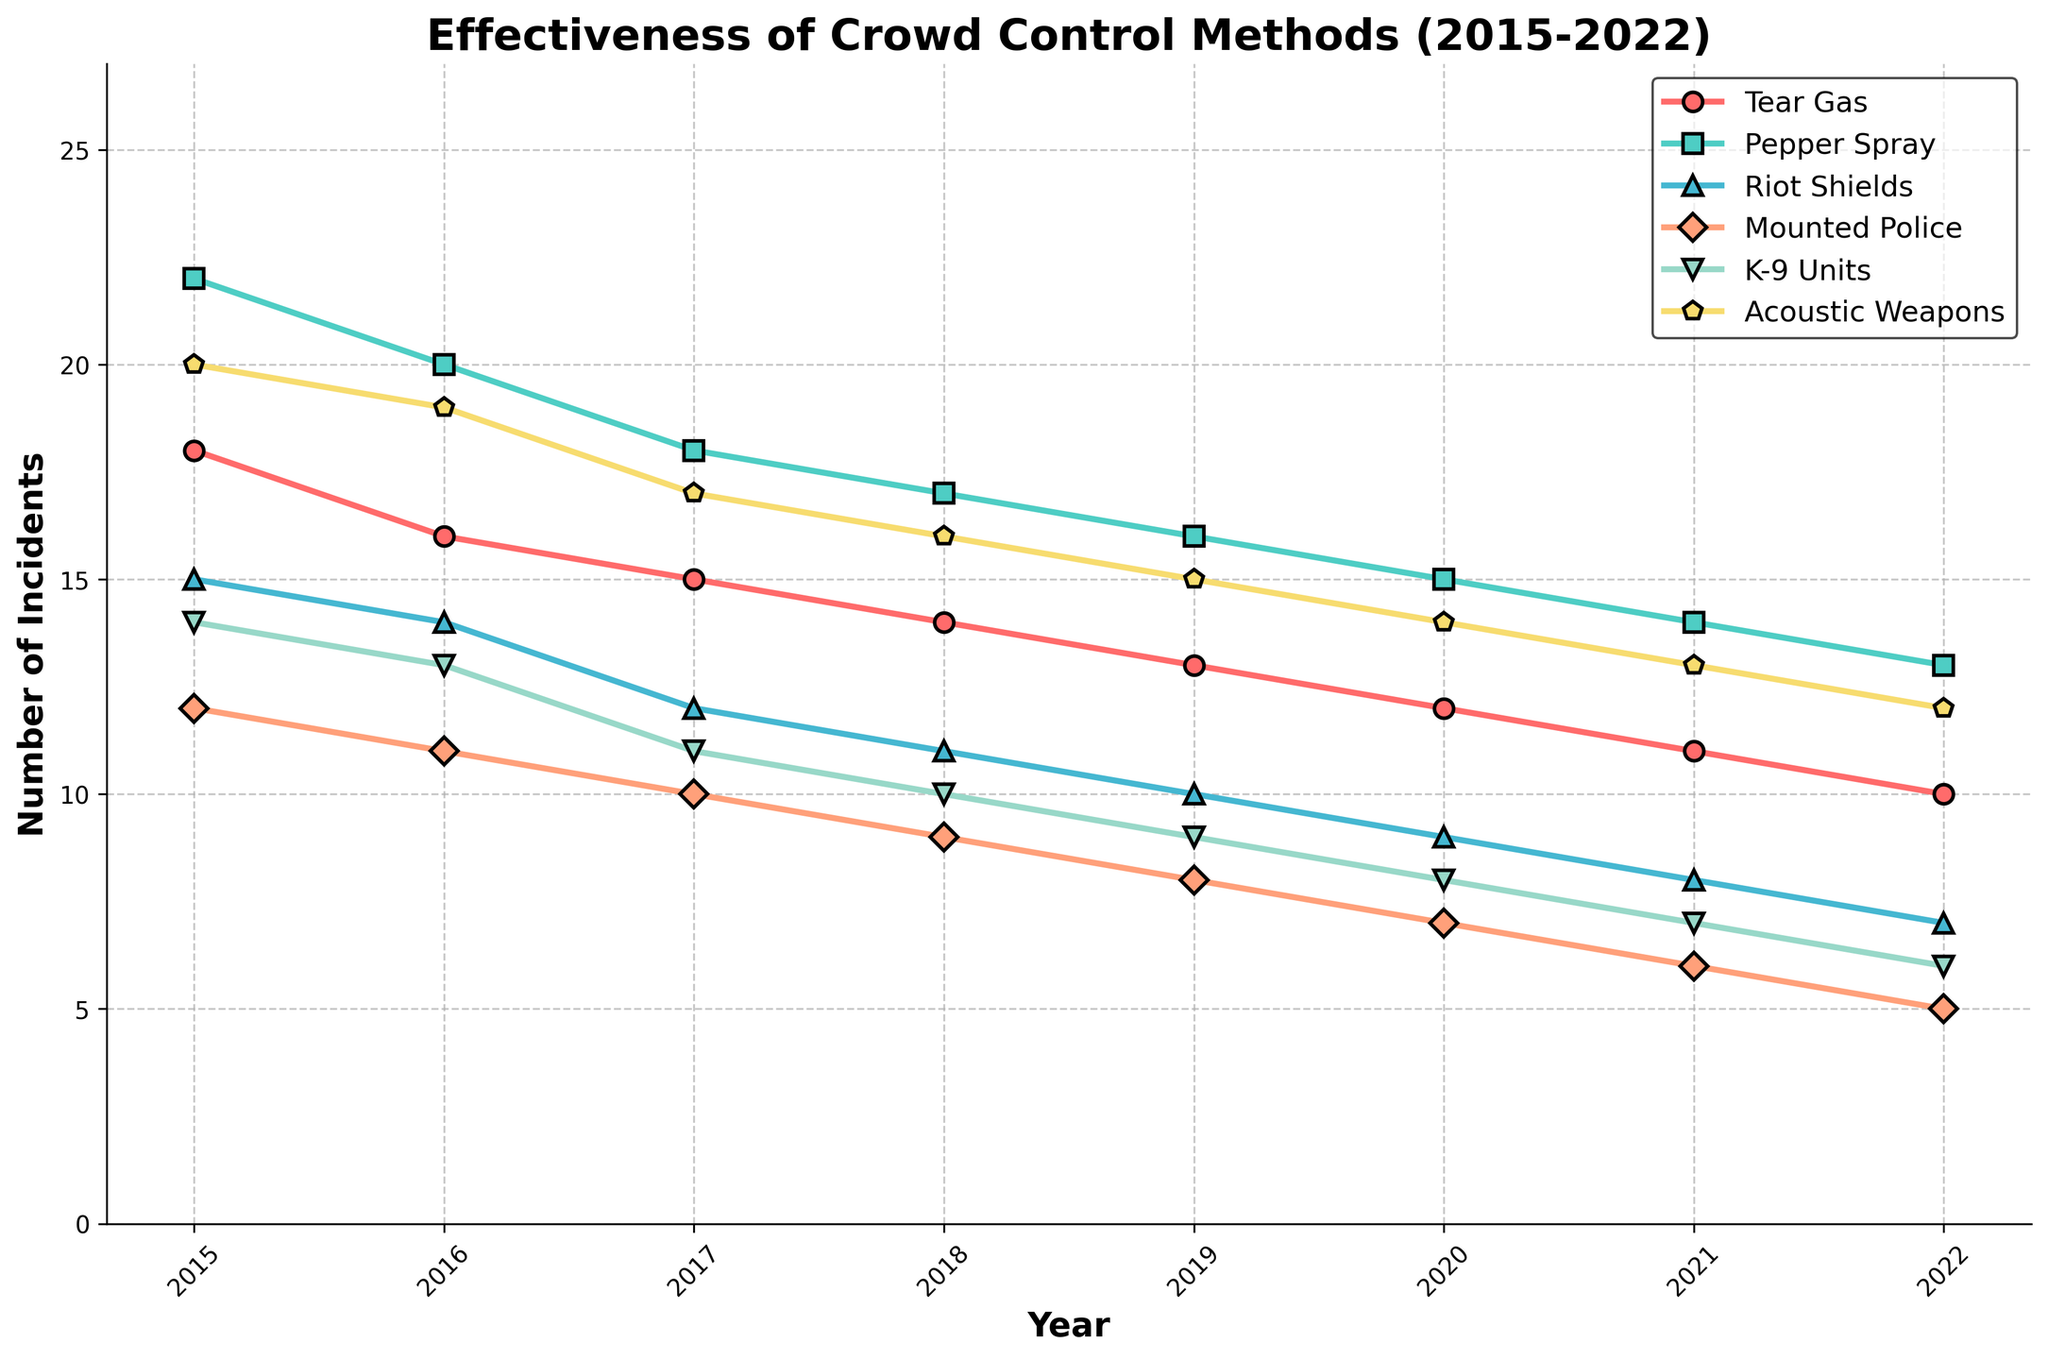What year had the highest number of incidents for Tear Gas? To determine the highest number of incidents for Tear Gas, look at the plotted data points representing Tear Gas and identify the maximum value along the y-axis. The year corresponding to this peak value is 2015.
Answer: 2015 Which crowd control method shows the largest decrease in number of incidents from 2015 to 2022? Calculate the difference in the number of incidents from 2015 to 2022 for each method. Tear Gas decreased from 18 to 10 (a decrease of 8), Pepper Spray from 22 to 13 (a decrease of 9), Riot Shields from 15 to 7 (a decrease of 8), Mounted Police from 12 to 5 (a decrease of 7), K-9 Units from 14 to 6 (a decrease of 8), and Acoustic Weapons from 20 to 12 (a decrease of 8). Pepper Spray has the largest decrease of 9.
Answer: Pepper Spray How many total incidents were there for Acoustic Weapons from 2015 to 2022? To find the total incidents for Acoustic Weapons, add the yearly values: 20 + 19 + 17 + 16 + 15 + 14 + 13 + 12 = 126.
Answer: 126 Which two crowd control methods had the same number of incidents in 2019? Look for lines that meet at the same y-value in 2019. Riot Shields and Mounted Police both had 10 incidents in 2019.
Answer: Riot Shields, Mounted Police By how many incidents did the number of incidents for Riot Shields decrease from 2016 to 2020? The number of incidents for Riot Shields decreased from 14 in 2016 to 9 in 2020. The decrease is 14 - 9 = 5.
Answer: 5 Which crowd control method had the most number of incidents in 2021? To determine which method had the highest number in 2021, compare the values in the plot for 2021. Pepper Spray had the highest number at 14 incidents.
Answer: Pepper Spray How many more incidents were there for Tear Gas compared to K-9 Units in 2019? Compare the number of incidents for Tear Gas and K-9 Units in 2019. Tear Gas had 13 incidents and K-9 Units had 9. The difference is 13 - 9 = 4.
Answer: 4 What is the average number of incidents per year for Mounted Police from 2015 to 2022? Calculate the average by summing the annual incidents and dividing by the number of years: (12 + 11 + 10 + 9 + 8 + 7 + 6 + 5)/8. Sum = 68, and the average is 68/8 = 8.5.
Answer: 8.5 In which year did Pepper Spray have exactly 3 more incidents than Acoustic Weapons? Compare the values of Pepper Spray and Acoustic Weapons year by year to find a year where their difference is 3. In 2017, Pepper Spray had 18 incidents and Acoustic Weapons had 15, which is a difference of 3.
Answer: 2017 